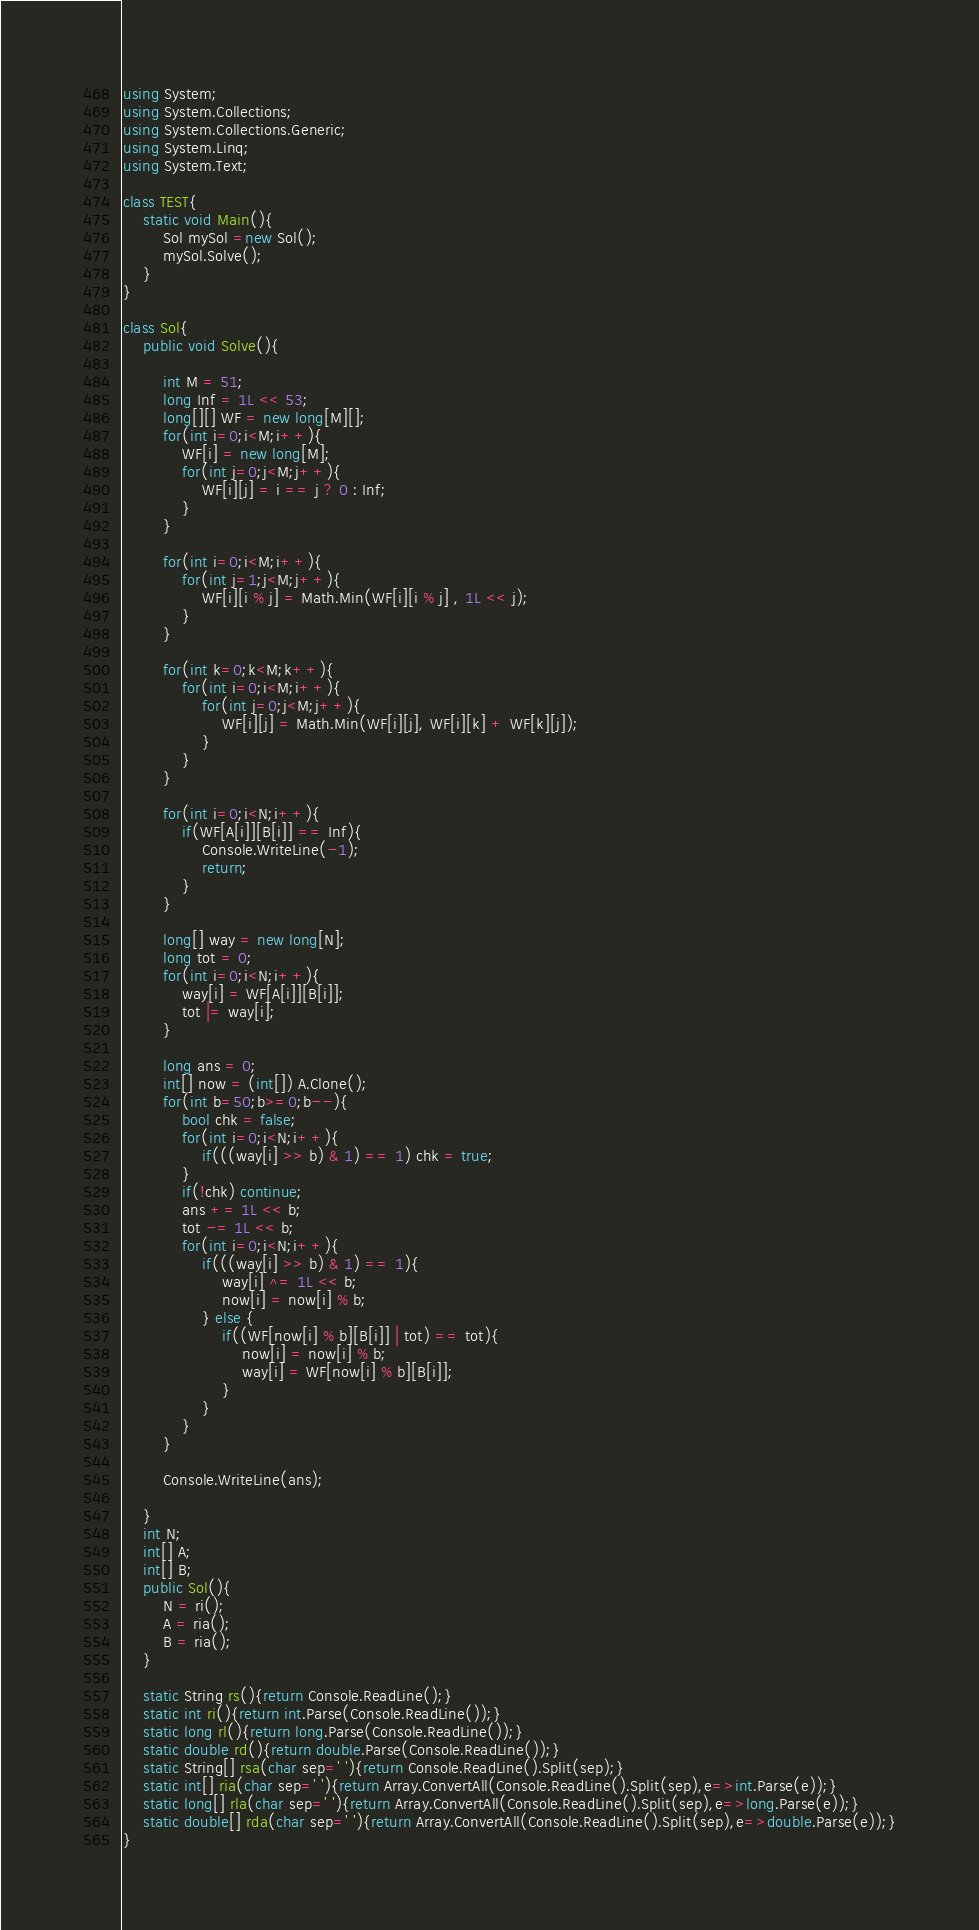<code> <loc_0><loc_0><loc_500><loc_500><_C#_>using System;
using System.Collections;
using System.Collections.Generic;
using System.Linq;
using System.Text;

class TEST{
	static void Main(){
		Sol mySol =new Sol();
		mySol.Solve();
	}
}

class Sol{
	public void Solve(){
		
		int M = 51;
		long Inf = 1L << 53;
		long[][] WF = new long[M][];
		for(int i=0;i<M;i++){
			WF[i] = new long[M];
			for(int j=0;j<M;j++){
				WF[i][j] = i == j ? 0 : Inf;
			}
		}
		
		for(int i=0;i<M;i++){
			for(int j=1;j<M;j++){
				WF[i][i % j] = Math.Min(WF[i][i % j] , 1L << j);
			}
		}
		
		for(int k=0;k<M;k++){
			for(int i=0;i<M;i++){
				for(int j=0;j<M;j++){
					WF[i][j] = Math.Min(WF[i][j], WF[i][k] + WF[k][j]);
				}
			}
		}
		
		for(int i=0;i<N;i++){
			if(WF[A[i]][B[i]] == Inf){
				Console.WriteLine(-1);
				return;
			}
		}
		
		long[] way = new long[N];
		long tot = 0;
		for(int i=0;i<N;i++){
			way[i] = WF[A[i]][B[i]];
			tot |= way[i];
		}
		
		long ans = 0;
		int[] now = (int[]) A.Clone();
		for(int b=50;b>=0;b--){
			bool chk = false;
			for(int i=0;i<N;i++){
				if(((way[i] >> b) & 1) == 1) chk = true;
			}
			if(!chk) continue;
			ans += 1L << b;
			tot -= 1L << b;
			for(int i=0;i<N;i++){
				if(((way[i] >> b) & 1) == 1){
					way[i] ^= 1L << b;
					now[i] = now[i] % b;
				} else {
					if((WF[now[i] % b][B[i]] | tot) == tot){
						now[i] = now[i] % b;
						way[i] = WF[now[i] % b][B[i]];
					}
				}
			}
		}
		
		Console.WriteLine(ans);
		
	}
	int N;
	int[] A;
	int[] B;
	public Sol(){
		N = ri();
		A = ria();
		B = ria();
	}

	static String rs(){return Console.ReadLine();}
	static int ri(){return int.Parse(Console.ReadLine());}
	static long rl(){return long.Parse(Console.ReadLine());}
	static double rd(){return double.Parse(Console.ReadLine());}
	static String[] rsa(char sep=' '){return Console.ReadLine().Split(sep);}
	static int[] ria(char sep=' '){return Array.ConvertAll(Console.ReadLine().Split(sep),e=>int.Parse(e));}
	static long[] rla(char sep=' '){return Array.ConvertAll(Console.ReadLine().Split(sep),e=>long.Parse(e));}
	static double[] rda(char sep=' '){return Array.ConvertAll(Console.ReadLine().Split(sep),e=>double.Parse(e));}
}
</code> 